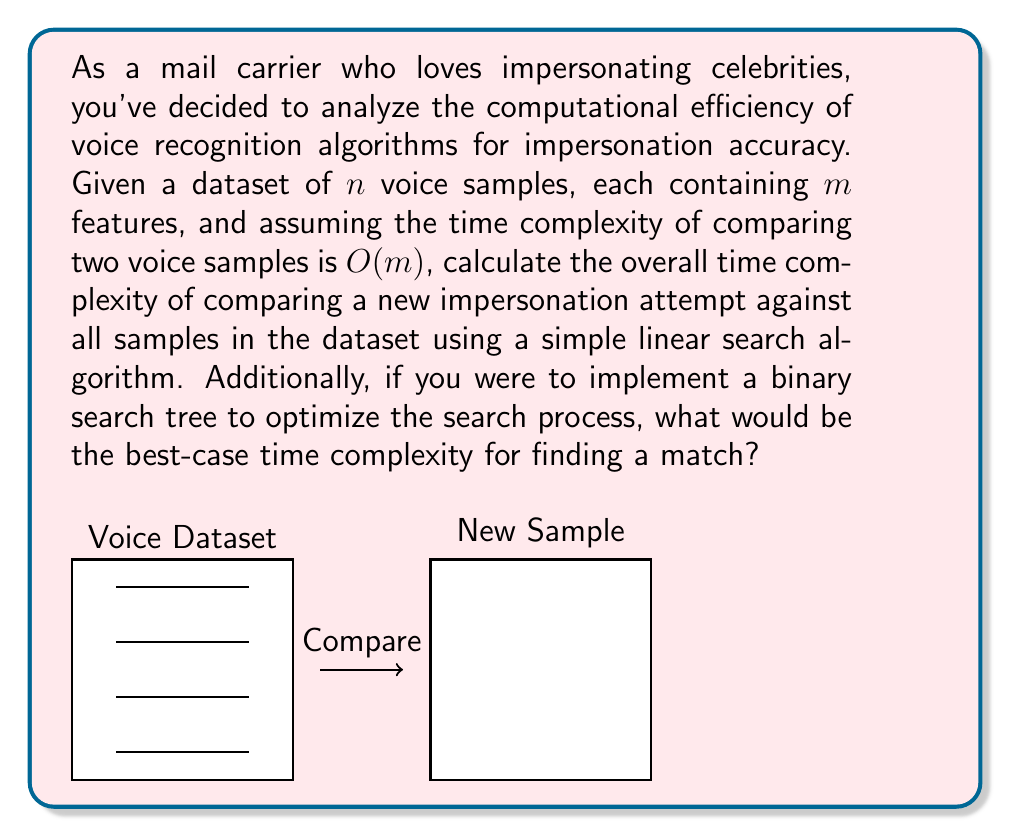Teach me how to tackle this problem. Let's break this down step-by-step:

1. Linear Search Algorithm:
   - We have $n$ voice samples in the dataset.
   - Each sample has $m$ features.
   - Comparing two samples takes $O(m)$ time.
   - We need to compare the new sample with all $n$ samples in the dataset.
   - Therefore, the time complexity for linear search is:
     $$O(n \cdot m)$$

2. Binary Search Tree Optimization:
   - To implement a binary search tree, we need to choose a feature or a combination of features as the key for comparison.
   - Building the BST with $n$ samples would take $O(n \log n)$ time.
   - In the best-case scenario (balanced tree), searching for a match would take $O(\log n)$ comparisons.
   - Each comparison still takes $O(m)$ time due to the feature comparison.
   - Thus, the best-case time complexity for finding a match using BST is:
     $$O(m \log n)$$

Note: The BST approach assumes that we can effectively order voice samples based on some feature(s). In practice, voice recognition often uses more complex algorithms like Hidden Markov Models or Deep Neural Networks, which have different computational complexities.
Answer: Linear search: $O(nm)$; BST best-case: $O(m \log n)$ 